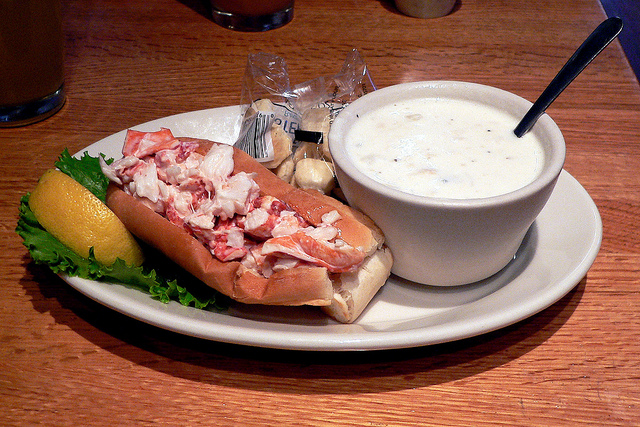<image>What Kind of topping is in the sandwich? I don't know what kind of topping is in the sandwich. It could be meat, lobster, crab, or bacon. What Kind of topping is in the sandwich? It is ambiguous what kind of topping is in the sandwich. It can be meat, lobster, crab, or bacon. 